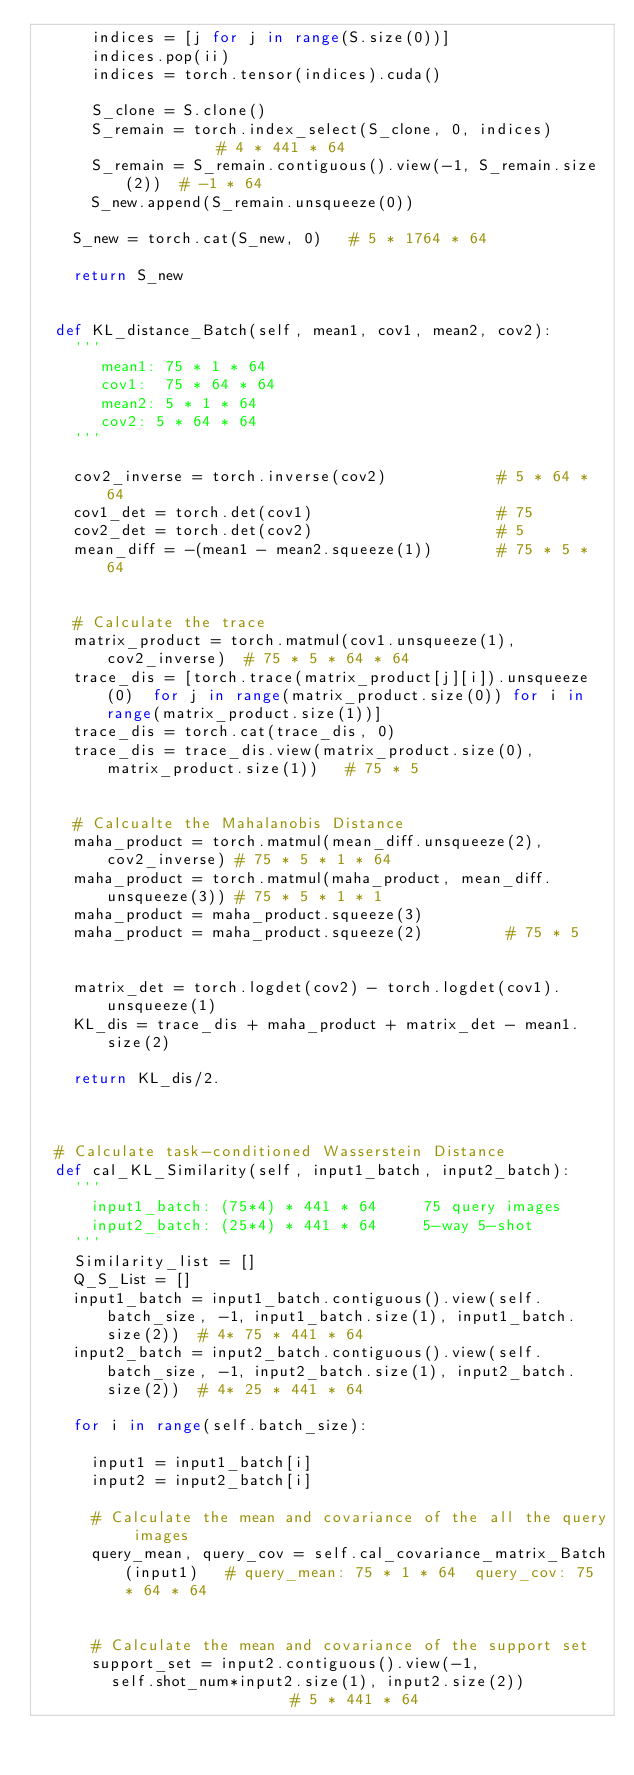<code> <loc_0><loc_0><loc_500><loc_500><_Python_>			indices = [j for j in range(S.size(0))]
			indices.pop(ii)
			indices = torch.tensor(indices).cuda()

			S_clone = S.clone()
			S_remain = torch.index_select(S_clone, 0, indices)           # 4 * 441 * 64
			S_remain = S_remain.contiguous().view(-1, S_remain.size(2))  # -1 * 64    
			S_new.append(S_remain.unsqueeze(0))

		S_new = torch.cat(S_new, 0)   # 5 * 1764 * 64 
		
		return S_new


	def KL_distance_Batch(self, mean1, cov1, mean2, cov2):
		'''
		   mean1: 75 * 1 * 64
		   cov1:  75 * 64 * 64
		   mean2: 5 * 1 * 64
		   cov2: 5 * 64 * 64
		'''
		
		cov2_inverse = torch.inverse(cov2)            # 5 * 64 * 64
		cov1_det = torch.det(cov1)                    # 75 
		cov2_det = torch.det(cov2)                    # 5 
		mean_diff = -(mean1 - mean2.squeeze(1))       # 75 * 5 * 64


		# Calculate the trace
		matrix_product = torch.matmul(cov1.unsqueeze(1), cov2_inverse)  # 75 * 5 * 64 * 64
		trace_dis = [torch.trace(matrix_product[j][i]).unsqueeze(0)  for j in range(matrix_product.size(0)) for i in range(matrix_product.size(1))]
		trace_dis = torch.cat(trace_dis, 0)
		trace_dis = trace_dis.view(matrix_product.size(0), matrix_product.size(1))   # 75 * 5 


		# Calcualte the Mahalanobis Distance
		maha_product = torch.matmul(mean_diff.unsqueeze(2), cov2_inverse) # 75 * 5 * 1 * 64
		maha_product = torch.matmul(maha_product, mean_diff.unsqueeze(3)) # 75 * 5 * 1 * 1
		maha_product = maha_product.squeeze(3) 
		maha_product = maha_product.squeeze(2)         # 75 * 5 


		matrix_det = torch.logdet(cov2) - torch.logdet(cov1).unsqueeze(1)
		KL_dis = trace_dis + maha_product + matrix_det - mean1.size(2)

		return KL_dis/2.



	# Calculate task-conditioned Wasserstein Distance
	def cal_KL_Similarity(self, input1_batch, input2_batch):
		'''
			input1_batch: (75*4) * 441 * 64     75 query images
			input2_batch: (25*4) * 441 * 64     5-way 5-shot 
		'''
		Similarity_list = []
		Q_S_List = []
		input1_batch = input1_batch.contiguous().view(self.batch_size, -1, input1_batch.size(1), input1_batch.size(2))  # 4* 75 * 441 * 64
		input2_batch = input2_batch.contiguous().view(self.batch_size, -1, input2_batch.size(1), input2_batch.size(2))  # 4* 25 * 441 * 64

		for i in range(self.batch_size):

			input1 = input1_batch[i]
			input2 = input2_batch[i]

			# Calculate the mean and covariance of the all the query images
			query_mean, query_cov = self.cal_covariance_matrix_Batch(input1)   # query_mean: 75 * 1 * 64  query_cov: 75 * 64 * 64
			

			# Calculate the mean and covariance of the support set
			support_set = input2.contiguous().view(-1, 
				self.shot_num*input2.size(1), input2.size(2))                 # 5 * 441 * 64    </code> 